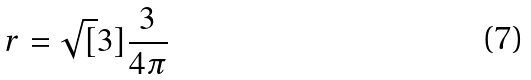<formula> <loc_0><loc_0><loc_500><loc_500>r = \sqrt { [ } 3 ] { \frac { 3 } { 4 \pi } }</formula> 